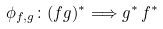Convert formula to latex. <formula><loc_0><loc_0><loc_500><loc_500>\phi _ { f , g } \colon ( f g ) ^ { \ast } \Longrightarrow g ^ { \ast } \, f ^ { \ast }</formula> 